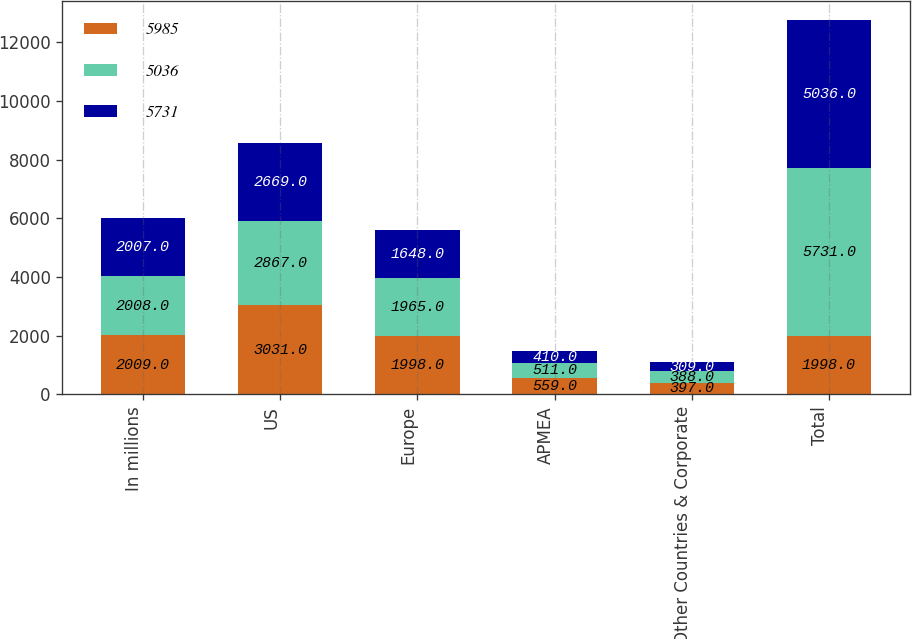Convert chart to OTSL. <chart><loc_0><loc_0><loc_500><loc_500><stacked_bar_chart><ecel><fcel>In millions<fcel>US<fcel>Europe<fcel>APMEA<fcel>Other Countries & Corporate<fcel>Total<nl><fcel>5985<fcel>2009<fcel>3031<fcel>1998<fcel>559<fcel>397<fcel>1998<nl><fcel>5036<fcel>2008<fcel>2867<fcel>1965<fcel>511<fcel>388<fcel>5731<nl><fcel>5731<fcel>2007<fcel>2669<fcel>1648<fcel>410<fcel>309<fcel>5036<nl></chart> 